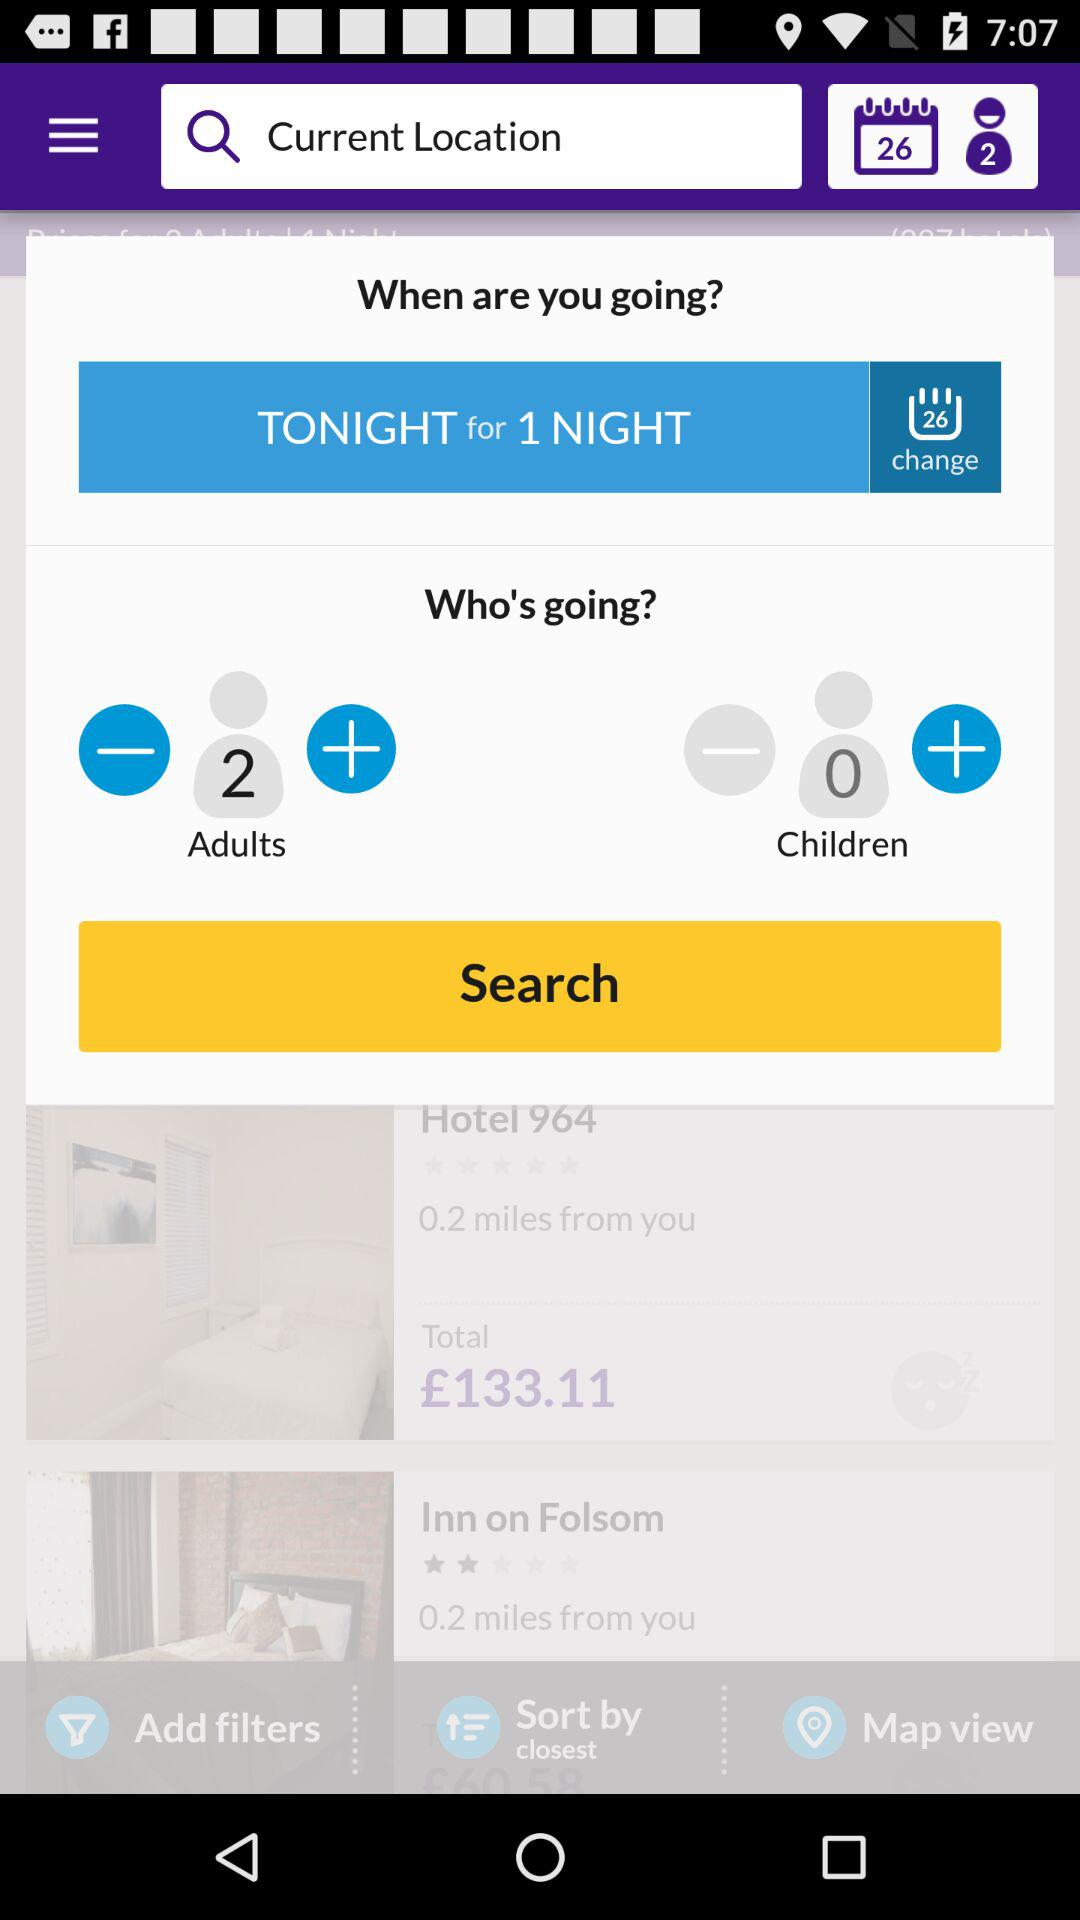How many more people are going than there are children?
Answer the question using a single word or phrase. 2 